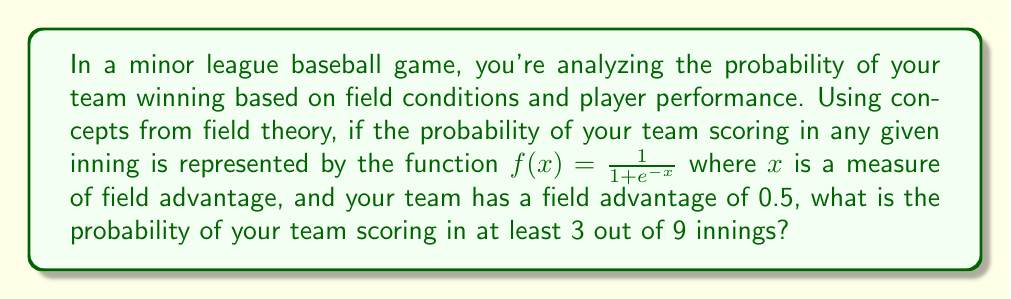Show me your answer to this math problem. Let's approach this step-by-step:

1) First, we need to calculate the probability of scoring in a single inning. We're given the logistic function $f(x) = \frac{1}{1 + e^{-x}}$ and $x = 0.5$.

   $p = f(0.5) = \frac{1}{1 + e^{-0.5}} \approx 0.6225$

2) Now, we have a binomial probability problem. We want the probability of scoring in at least 3 out of 9 innings. This is equivalent to 1 minus the probability of scoring in 0, 1, or 2 innings.

3) Let's use the binomial probability formula:

   $P(X = k) = \binom{n}{k} p^k (1-p)^{n-k}$

   Where $n = 9$ (total innings), $k$ is the number of successful innings, $p = 0.6225$

4) We need to calculate:

   $1 - [P(X = 0) + P(X = 1) + P(X = 2)]$

5) Let's calculate each term:

   $P(X = 0) = \binom{9}{0} (0.6225)^0 (0.3775)^9 \approx 0.0001$
   
   $P(X = 1) = \binom{9}{1} (0.6225)^1 (0.3775)^8 \approx 0.0014$
   
   $P(X = 2) = \binom{9}{2} (0.6225)^2 (0.3775)^7 \approx 0.0104$

6) Now, we can subtract from 1:

   $1 - (0.0001 + 0.0014 + 0.0104) = 0.9881$

Therefore, the probability of scoring in at least 3 out of 9 innings is approximately 0.9881 or 98.81%.
Answer: 0.9881 